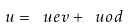<formula> <loc_0><loc_0><loc_500><loc_500>u = \ u e v + \ u o d</formula> 